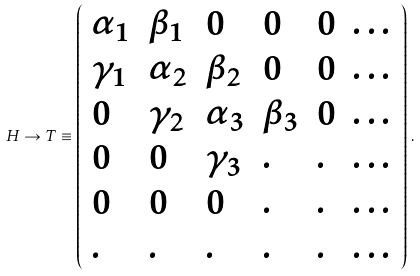Convert formula to latex. <formula><loc_0><loc_0><loc_500><loc_500>H \rightarrow T \equiv \left ( \begin{array} { l l l l l l } \alpha _ { 1 } & \beta _ { 1 } & 0 & 0 & 0 & \dots \\ \gamma _ { 1 } & \alpha _ { 2 } & \beta _ { 2 } & 0 & 0 & \dots \\ 0 & \gamma _ { 2 } & \alpha _ { 3 } & \beta _ { 3 } & 0 & \dots \\ 0 & 0 & \gamma _ { 3 } & . & . & \dots \\ 0 & 0 & 0 & . & . & \dots \\ . & . & . & . & . & \dots \end{array} \right ) \, .</formula> 